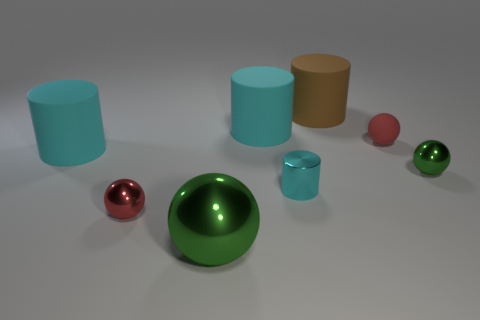Is the number of blue cubes less than the number of tiny green spheres?
Offer a very short reply. Yes. There is a large rubber cylinder that is on the left side of the big green object; what color is it?
Your response must be concise. Cyan. There is a tiny red thing on the right side of the brown matte cylinder that is behind the large metallic ball; what is its shape?
Provide a succinct answer. Sphere. Is the tiny cyan thing made of the same material as the big object that is right of the shiny cylinder?
Your response must be concise. No. How many cyan rubber cylinders have the same size as the brown rubber cylinder?
Give a very brief answer. 2. Are there fewer big green metal balls on the right side of the brown cylinder than tiny cyan objects?
Your response must be concise. Yes. There is a rubber ball; how many rubber objects are behind it?
Make the answer very short. 2. What is the size of the metal sphere on the right side of the sphere behind the cyan rubber cylinder in front of the tiny red matte object?
Give a very brief answer. Small. There is a big brown object; is it the same shape as the large cyan rubber thing to the left of the big metallic sphere?
Give a very brief answer. Yes. The green thing that is made of the same material as the tiny green sphere is what size?
Keep it short and to the point. Large. 